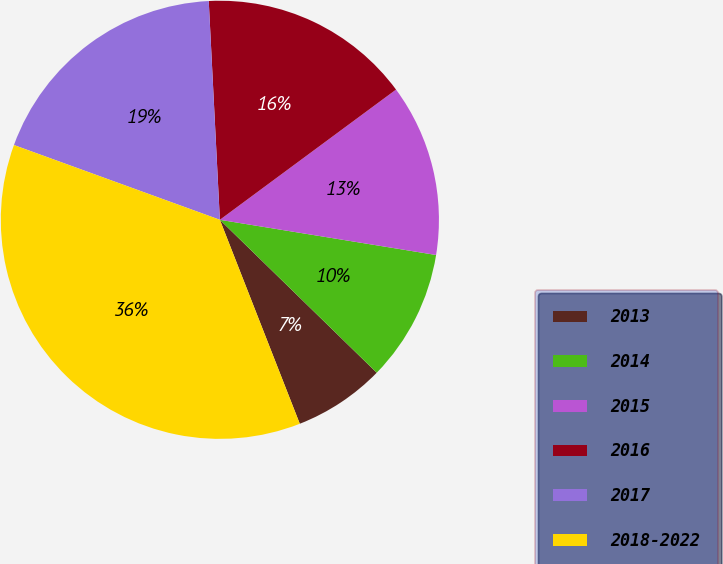Convert chart. <chart><loc_0><loc_0><loc_500><loc_500><pie_chart><fcel>2013<fcel>2014<fcel>2015<fcel>2016<fcel>2017<fcel>2018-2022<nl><fcel>6.76%<fcel>9.73%<fcel>12.7%<fcel>15.68%<fcel>18.65%<fcel>36.49%<nl></chart> 